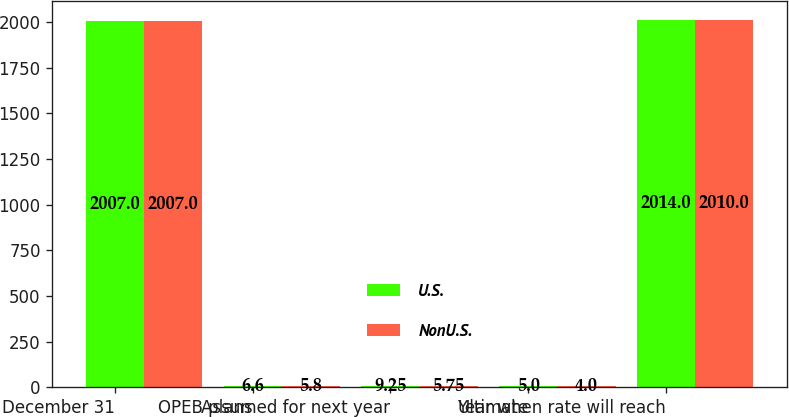Convert chart to OTSL. <chart><loc_0><loc_0><loc_500><loc_500><stacked_bar_chart><ecel><fcel>December 31<fcel>OPEB plans<fcel>Assumed for next year<fcel>Ultimate<fcel>Year when rate will reach<nl><fcel>U.S.<fcel>2007<fcel>6.6<fcel>9.25<fcel>5<fcel>2014<nl><fcel>NonU.S.<fcel>2007<fcel>5.8<fcel>5.75<fcel>4<fcel>2010<nl></chart> 